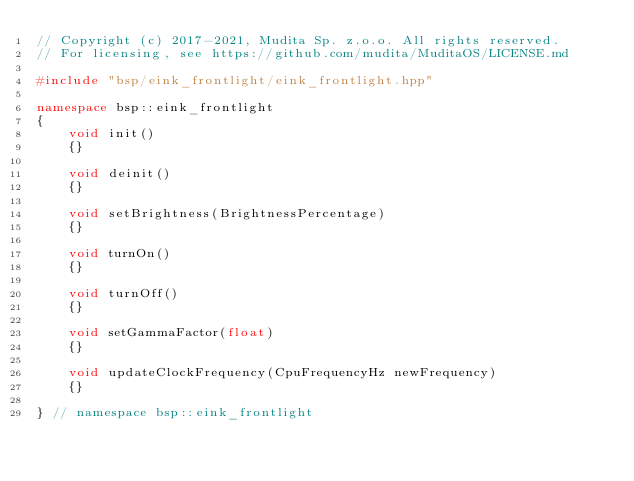<code> <loc_0><loc_0><loc_500><loc_500><_C++_>// Copyright (c) 2017-2021, Mudita Sp. z.o.o. All rights reserved.
// For licensing, see https://github.com/mudita/MuditaOS/LICENSE.md

#include "bsp/eink_frontlight/eink_frontlight.hpp"

namespace bsp::eink_frontlight
{
    void init()
    {}

    void deinit()
    {}

    void setBrightness(BrightnessPercentage)
    {}

    void turnOn()
    {}

    void turnOff()
    {}

    void setGammaFactor(float)
    {}

    void updateClockFrequency(CpuFrequencyHz newFrequency)
    {}

} // namespace bsp::eink_frontlight
</code> 